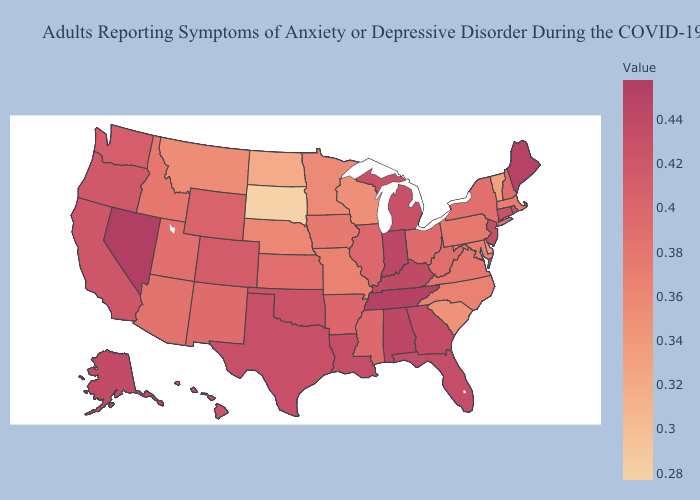Which states have the lowest value in the USA?
Answer briefly. South Dakota. Does the map have missing data?
Concise answer only. No. Which states hav the highest value in the South?
Be succinct. Tennessee. Does Maine have a higher value than Minnesota?
Quick response, please. Yes. Among the states that border Ohio , which have the highest value?
Short answer required. Indiana. Which states have the lowest value in the MidWest?
Quick response, please. South Dakota. Among the states that border Maine , which have the highest value?
Be succinct. New Hampshire. Which states have the lowest value in the USA?
Give a very brief answer. South Dakota. Which states have the lowest value in the USA?
Give a very brief answer. South Dakota. 